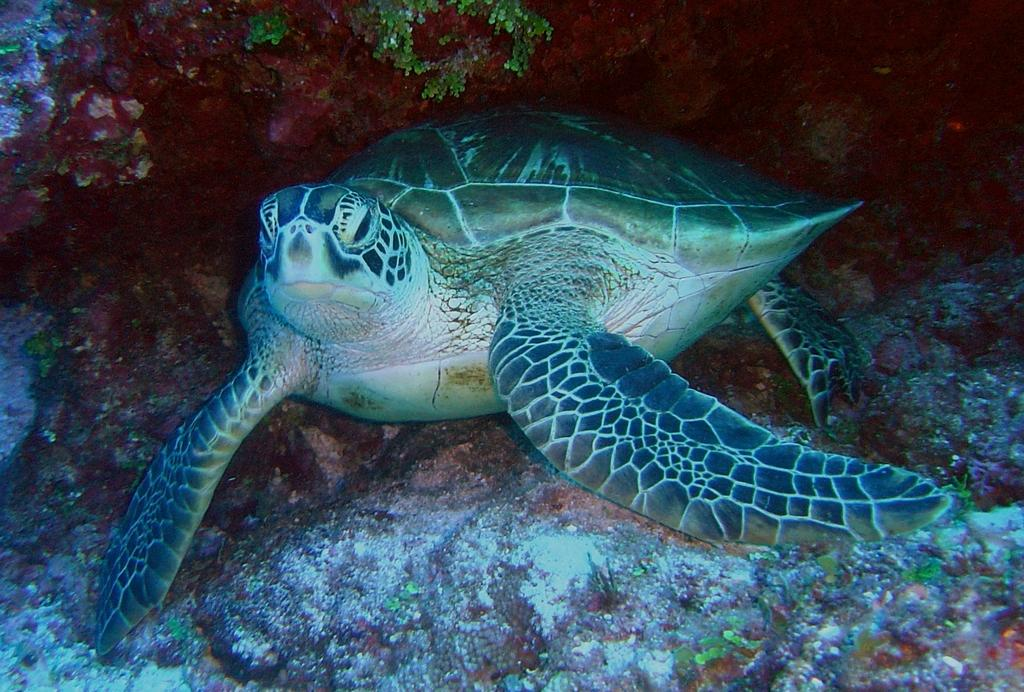What animal is located in the center of the image? There is a turtle in the center of the image. What type of vegetation can be seen at the top of the image? There is grass visible at the top of the image. How many pigs are standing on the turtle's back in the image? There are no pigs present in the image; it only features a turtle. What type of root can be seen growing from the turtle's shell in the image? There is no root growing from the turtle's shell in the image; it only features a turtle and grass. 